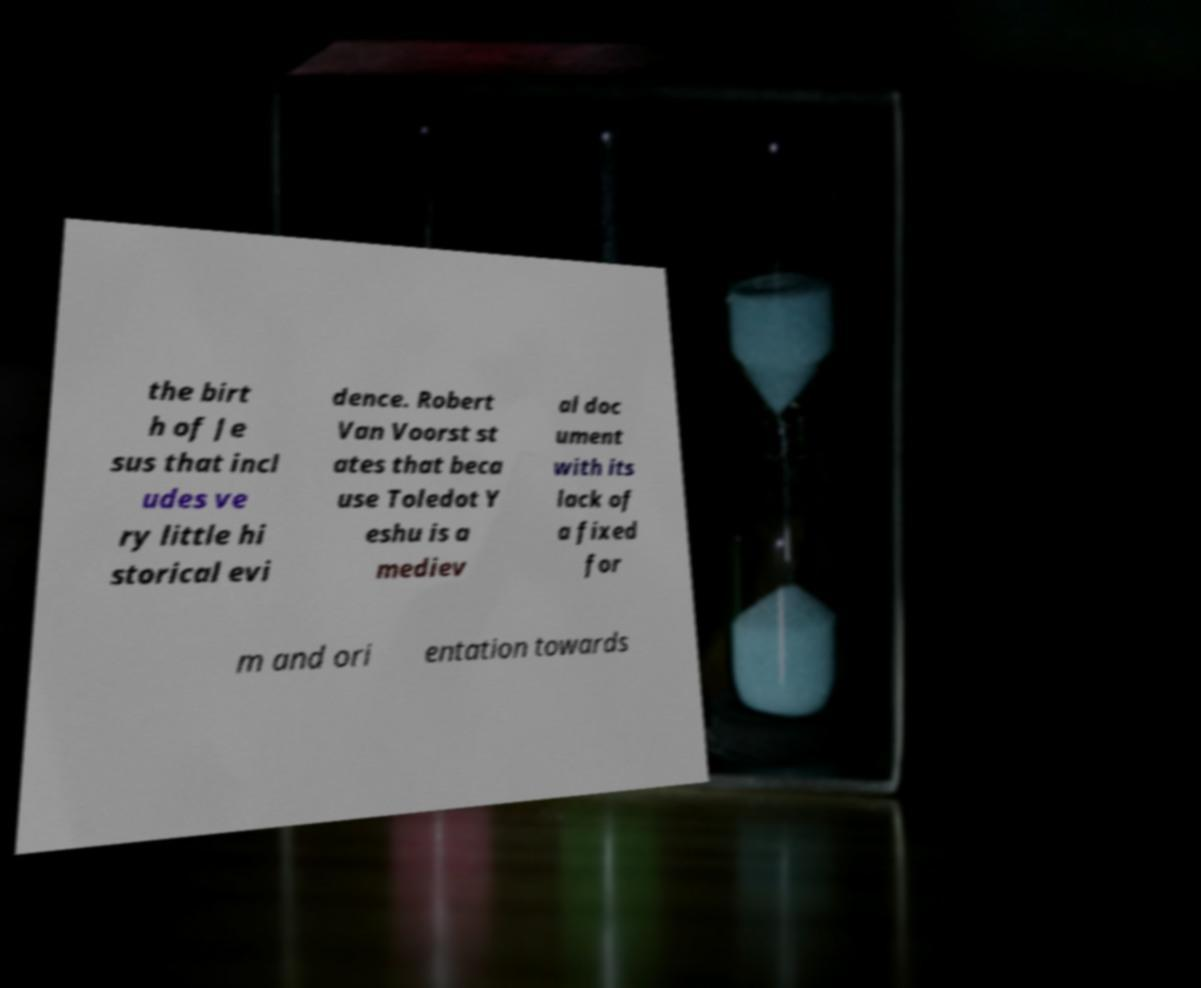For documentation purposes, I need the text within this image transcribed. Could you provide that? the birt h of Je sus that incl udes ve ry little hi storical evi dence. Robert Van Voorst st ates that beca use Toledot Y eshu is a mediev al doc ument with its lack of a fixed for m and ori entation towards 